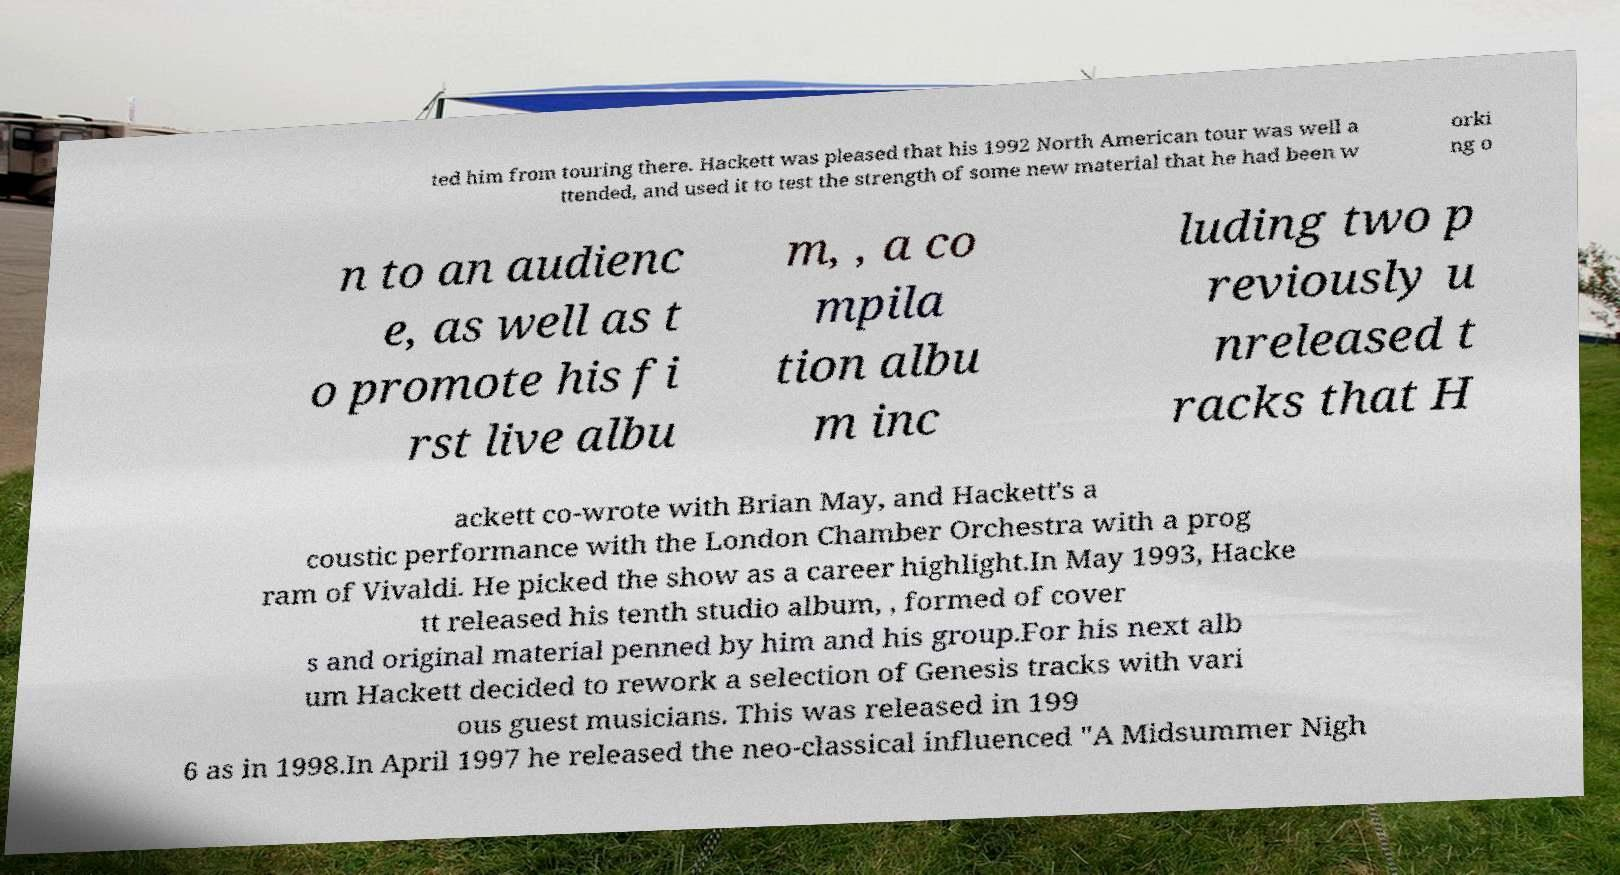I need the written content from this picture converted into text. Can you do that? ted him from touring there. Hackett was pleased that his 1992 North American tour was well a ttended, and used it to test the strength of some new material that he had been w orki ng o n to an audienc e, as well as t o promote his fi rst live albu m, , a co mpila tion albu m inc luding two p reviously u nreleased t racks that H ackett co-wrote with Brian May, and Hackett's a coustic performance with the London Chamber Orchestra with a prog ram of Vivaldi. He picked the show as a career highlight.In May 1993, Hacke tt released his tenth studio album, , formed of cover s and original material penned by him and his group.For his next alb um Hackett decided to rework a selection of Genesis tracks with vari ous guest musicians. This was released in 199 6 as in 1998.In April 1997 he released the neo-classical influenced "A Midsummer Nigh 